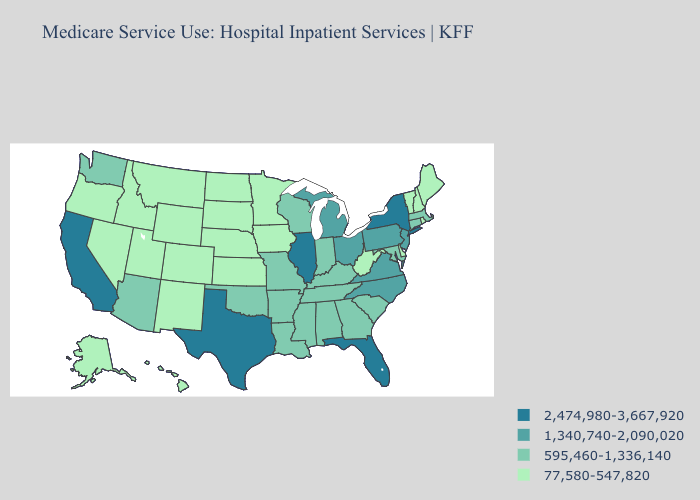Does the first symbol in the legend represent the smallest category?
Quick response, please. No. What is the lowest value in the South?
Short answer required. 77,580-547,820. Does Virginia have the highest value in the USA?
Give a very brief answer. No. Name the states that have a value in the range 77,580-547,820?
Write a very short answer. Alaska, Colorado, Delaware, Hawaii, Idaho, Iowa, Kansas, Maine, Minnesota, Montana, Nebraska, Nevada, New Hampshire, New Mexico, North Dakota, Oregon, Rhode Island, South Dakota, Utah, Vermont, West Virginia, Wyoming. What is the value of Kansas?
Answer briefly. 77,580-547,820. Name the states that have a value in the range 2,474,980-3,667,920?
Quick response, please. California, Florida, Illinois, New York, Texas. Name the states that have a value in the range 2,474,980-3,667,920?
Keep it brief. California, Florida, Illinois, New York, Texas. Name the states that have a value in the range 77,580-547,820?
Answer briefly. Alaska, Colorado, Delaware, Hawaii, Idaho, Iowa, Kansas, Maine, Minnesota, Montana, Nebraska, Nevada, New Hampshire, New Mexico, North Dakota, Oregon, Rhode Island, South Dakota, Utah, Vermont, West Virginia, Wyoming. Among the states that border Louisiana , does Texas have the lowest value?
Short answer required. No. Does the map have missing data?
Give a very brief answer. No. Does Illinois have the lowest value in the USA?
Quick response, please. No. Which states hav the highest value in the South?
Keep it brief. Florida, Texas. What is the value of West Virginia?
Write a very short answer. 77,580-547,820. What is the value of Arizona?
Quick response, please. 595,460-1,336,140. 